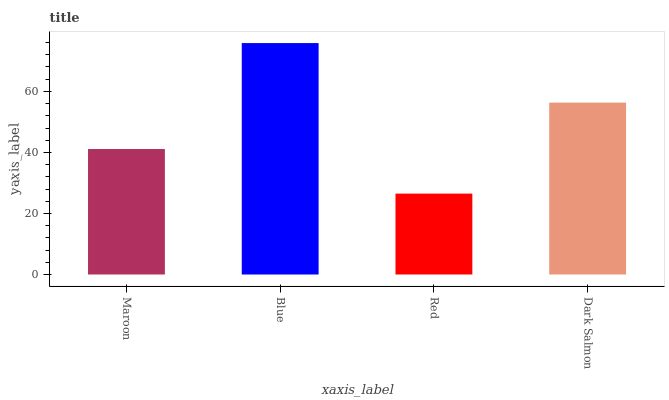Is Red the minimum?
Answer yes or no. Yes. Is Blue the maximum?
Answer yes or no. Yes. Is Blue the minimum?
Answer yes or no. No. Is Red the maximum?
Answer yes or no. No. Is Blue greater than Red?
Answer yes or no. Yes. Is Red less than Blue?
Answer yes or no. Yes. Is Red greater than Blue?
Answer yes or no. No. Is Blue less than Red?
Answer yes or no. No. Is Dark Salmon the high median?
Answer yes or no. Yes. Is Maroon the low median?
Answer yes or no. Yes. Is Red the high median?
Answer yes or no. No. Is Blue the low median?
Answer yes or no. No. 